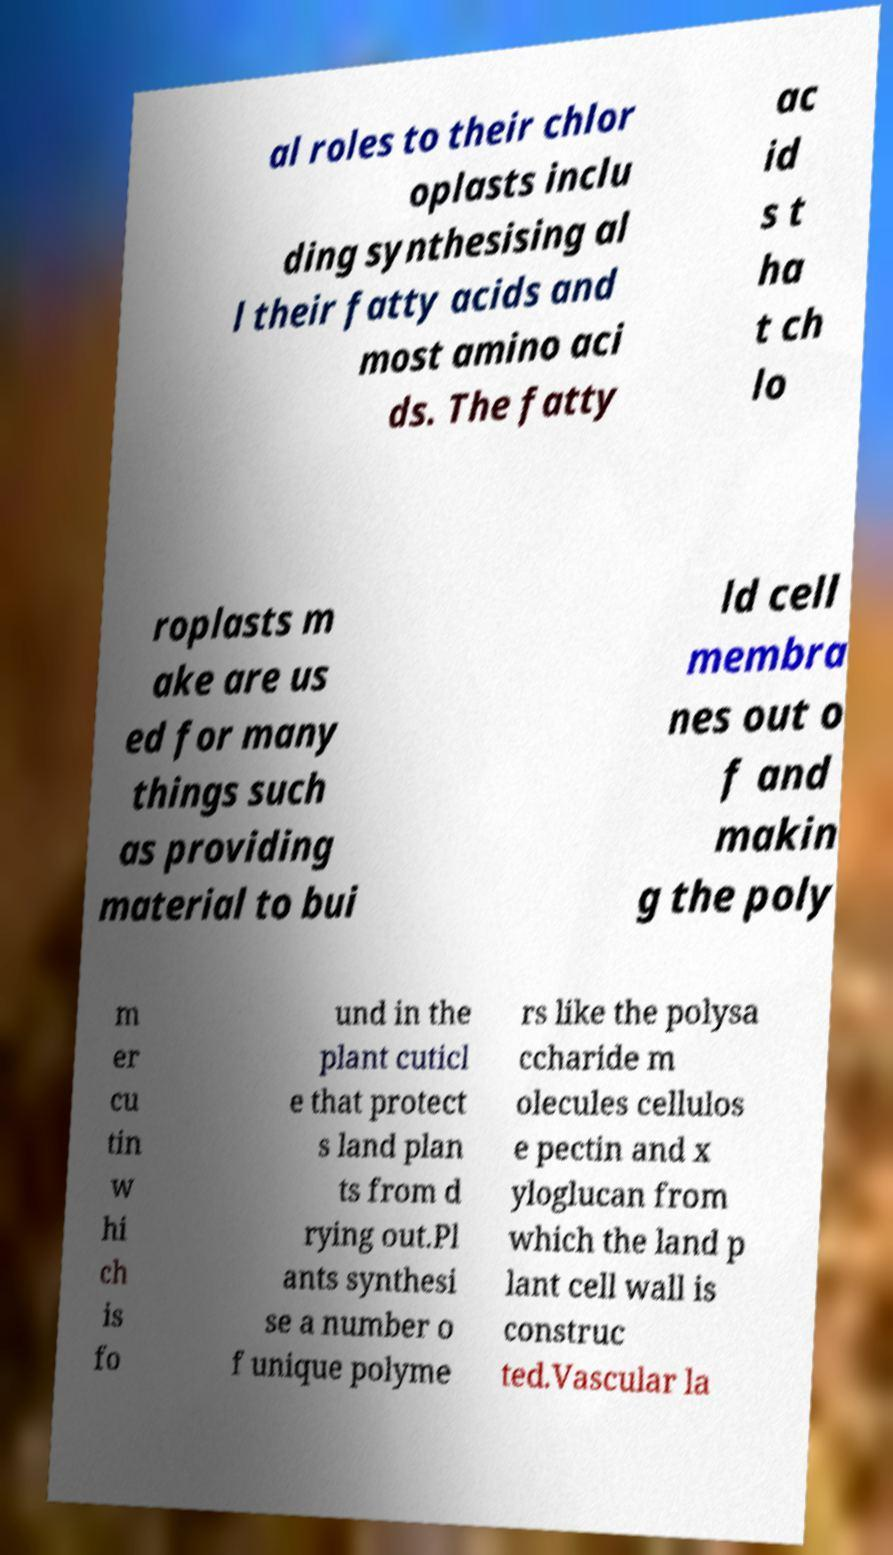For documentation purposes, I need the text within this image transcribed. Could you provide that? al roles to their chlor oplasts inclu ding synthesising al l their fatty acids and most amino aci ds. The fatty ac id s t ha t ch lo roplasts m ake are us ed for many things such as providing material to bui ld cell membra nes out o f and makin g the poly m er cu tin w hi ch is fo und in the plant cuticl e that protect s land plan ts from d rying out.Pl ants synthesi se a number o f unique polyme rs like the polysa ccharide m olecules cellulos e pectin and x yloglucan from which the land p lant cell wall is construc ted.Vascular la 